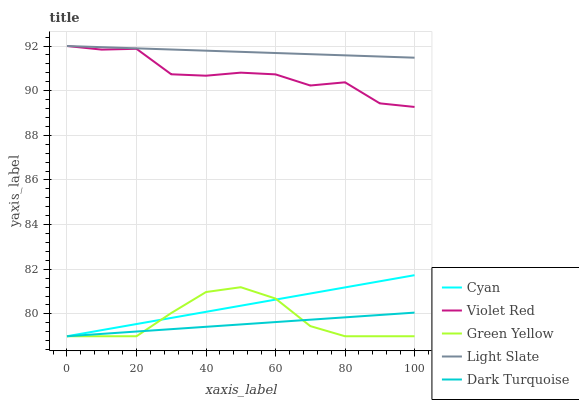Does Dark Turquoise have the minimum area under the curve?
Answer yes or no. Yes. Does Light Slate have the maximum area under the curve?
Answer yes or no. Yes. Does Cyan have the minimum area under the curve?
Answer yes or no. No. Does Cyan have the maximum area under the curve?
Answer yes or no. No. Is Dark Turquoise the smoothest?
Answer yes or no. Yes. Is Violet Red the roughest?
Answer yes or no. Yes. Is Cyan the smoothest?
Answer yes or no. No. Is Cyan the roughest?
Answer yes or no. No. Does Cyan have the lowest value?
Answer yes or no. Yes. Does Violet Red have the lowest value?
Answer yes or no. No. Does Violet Red have the highest value?
Answer yes or no. Yes. Does Cyan have the highest value?
Answer yes or no. No. Is Dark Turquoise less than Violet Red?
Answer yes or no. Yes. Is Violet Red greater than Green Yellow?
Answer yes or no. Yes. Does Violet Red intersect Light Slate?
Answer yes or no. Yes. Is Violet Red less than Light Slate?
Answer yes or no. No. Is Violet Red greater than Light Slate?
Answer yes or no. No. Does Dark Turquoise intersect Violet Red?
Answer yes or no. No. 